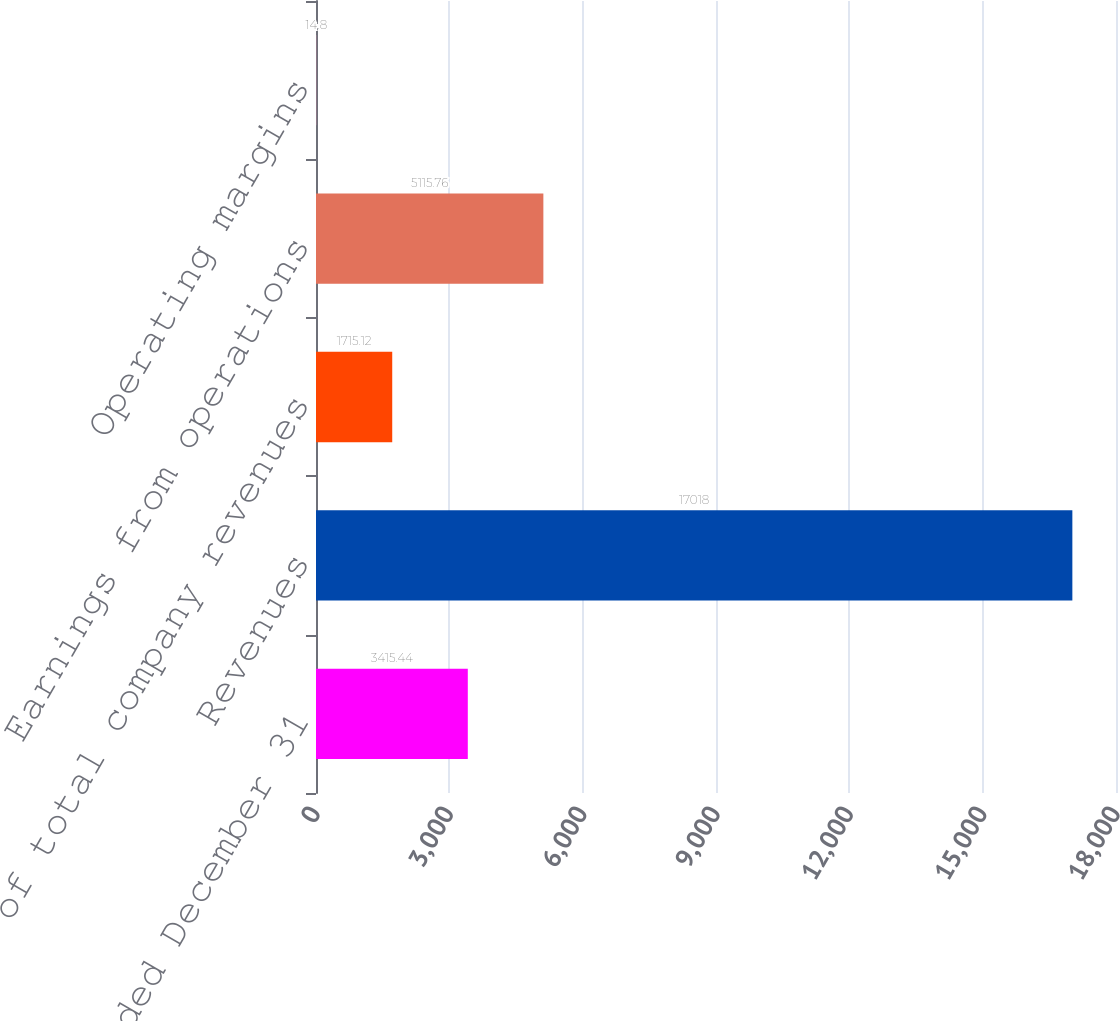<chart> <loc_0><loc_0><loc_500><loc_500><bar_chart><fcel>Years ended December 31<fcel>Revenues<fcel>of total company revenues<fcel>Earnings from operations<fcel>Operating margins<nl><fcel>3415.44<fcel>17018<fcel>1715.12<fcel>5115.76<fcel>14.8<nl></chart> 